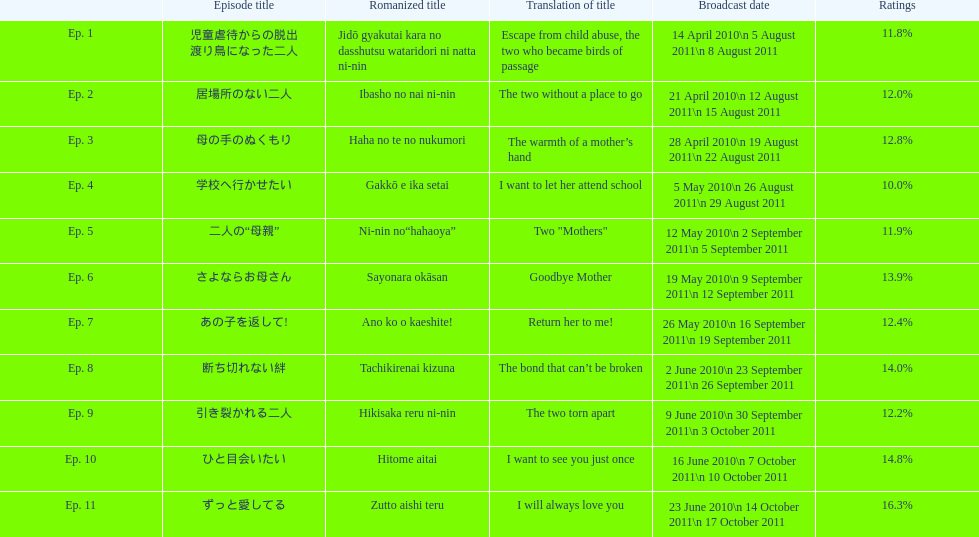Can you give me this table as a dict? {'header': ['', 'Episode title', 'Romanized title', 'Translation of title', 'Broadcast date', 'Ratings'], 'rows': [['Ep. 1', '児童虐待からの脱出 渡り鳥になった二人', 'Jidō gyakutai kara no dasshutsu wataridori ni natta ni-nin', 'Escape from child abuse, the two who became birds of passage', '14 April 2010\\n 5 August 2011\\n 8 August 2011', '11.8%'], ['Ep. 2', '居場所のない二人', 'Ibasho no nai ni-nin', 'The two without a place to go', '21 April 2010\\n 12 August 2011\\n 15 August 2011', '12.0%'], ['Ep. 3', '母の手のぬくもり', 'Haha no te no nukumori', 'The warmth of a mother’s hand', '28 April 2010\\n 19 August 2011\\n 22 August 2011', '12.8%'], ['Ep. 4', '学校へ行かせたい', 'Gakkō e ika setai', 'I want to let her attend school', '5 May 2010\\n 26 August 2011\\n 29 August 2011', '10.0%'], ['Ep. 5', '二人の“母親”', 'Ni-nin no“hahaoya”', 'Two "Mothers"', '12 May 2010\\n 2 September 2011\\n 5 September 2011', '11.9%'], ['Ep. 6', 'さよならお母さん', 'Sayonara okāsan', 'Goodbye Mother', '19 May 2010\\n 9 September 2011\\n 12 September 2011', '13.9%'], ['Ep. 7', 'あの子を返して!', 'Ano ko o kaeshite!', 'Return her to me!', '26 May 2010\\n 16 September 2011\\n 19 September 2011', '12.4%'], ['Ep. 8', '断ち切れない絆', 'Tachikirenai kizuna', 'The bond that can’t be broken', '2 June 2010\\n 23 September 2011\\n 26 September 2011', '14.0%'], ['Ep. 9', '引き裂かれる二人', 'Hikisaka reru ni-nin', 'The two torn apart', '9 June 2010\\n 30 September 2011\\n 3 October 2011', '12.2%'], ['Ep. 10', 'ひと目会いたい', 'Hitome aitai', 'I want to see you just once', '16 June 2010\\n 7 October 2011\\n 10 October 2011', '14.8%'], ['Ep. 11', 'ずっと愛してる', 'Zutto aishi teru', 'I will always love you', '23 June 2010\\n 14 October 2011\\n 17 October 2011', '16.3%']]} Can you provide the count of episodes mentioned? 11. 